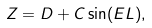<formula> <loc_0><loc_0><loc_500><loc_500>Z = D + C \sin ( E L ) ,</formula> 